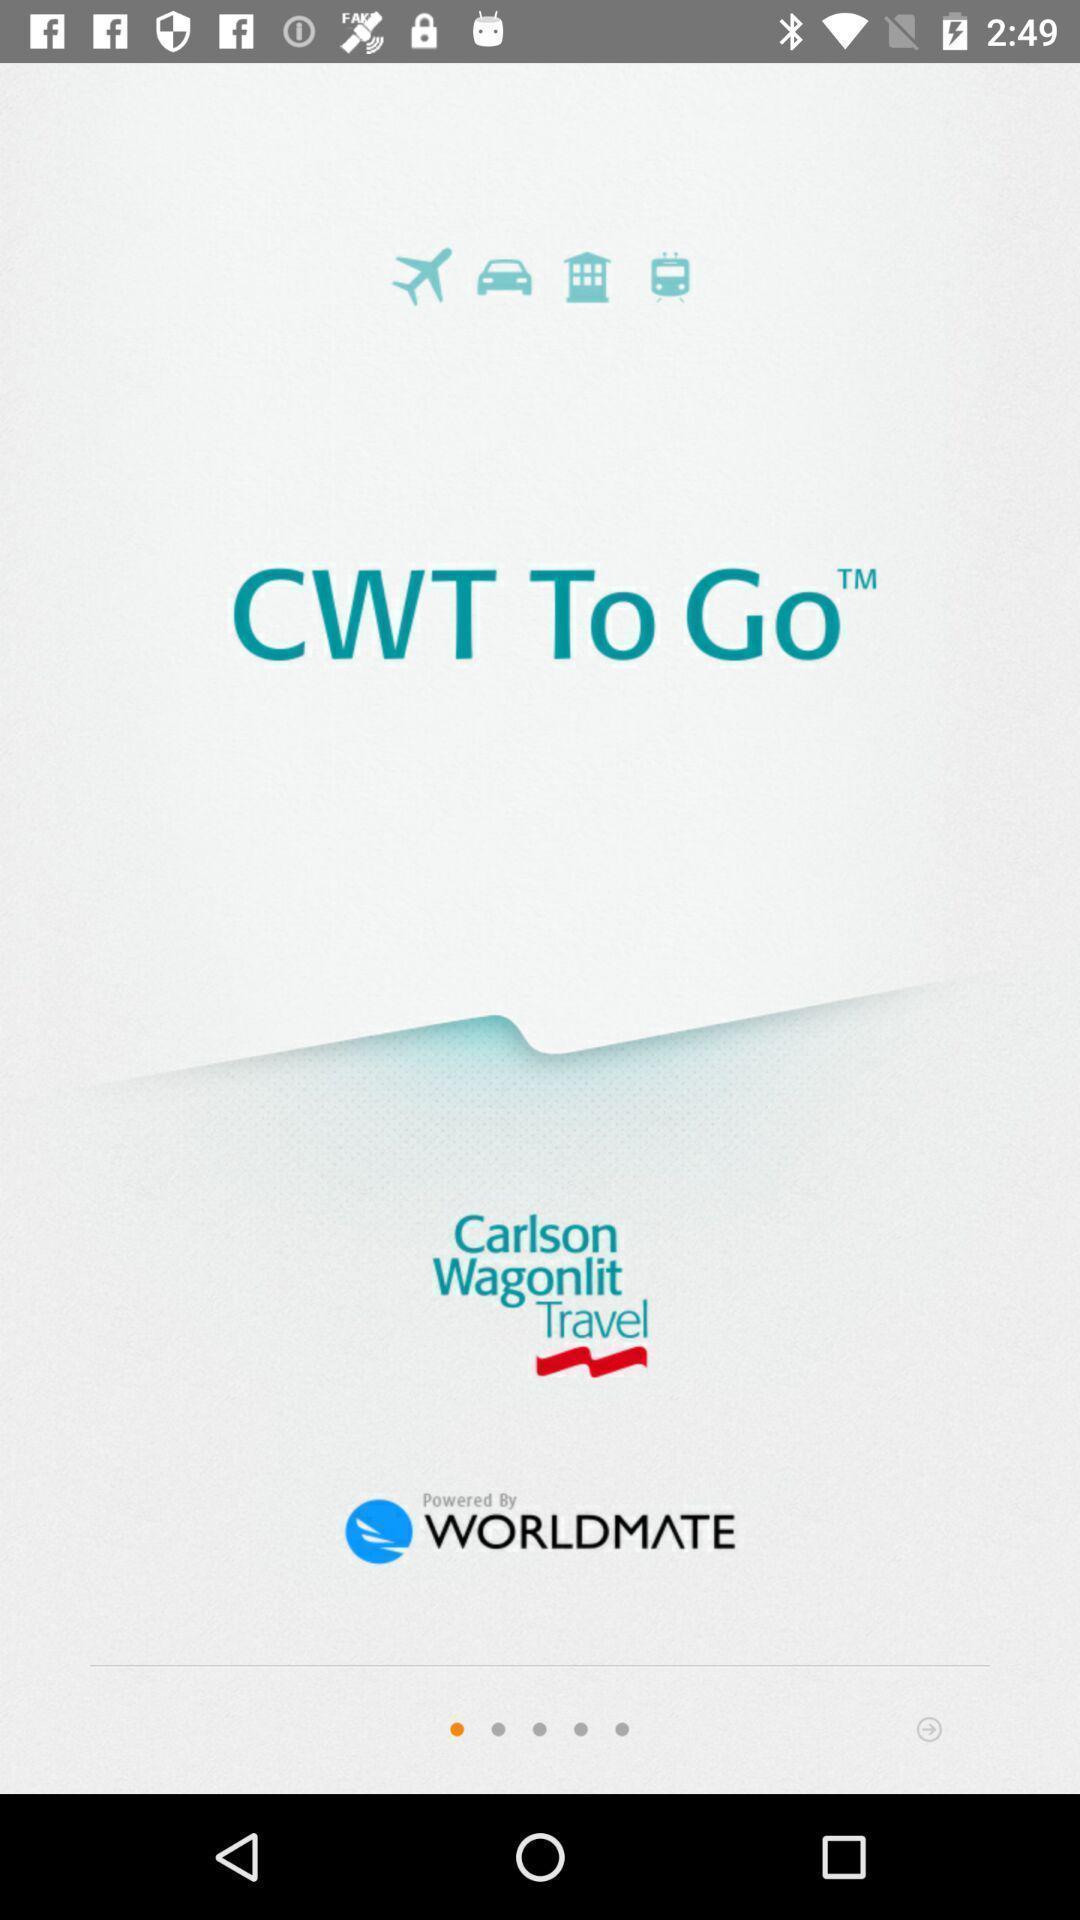Give me a summary of this screen capture. Welcome page of a online booking application. 